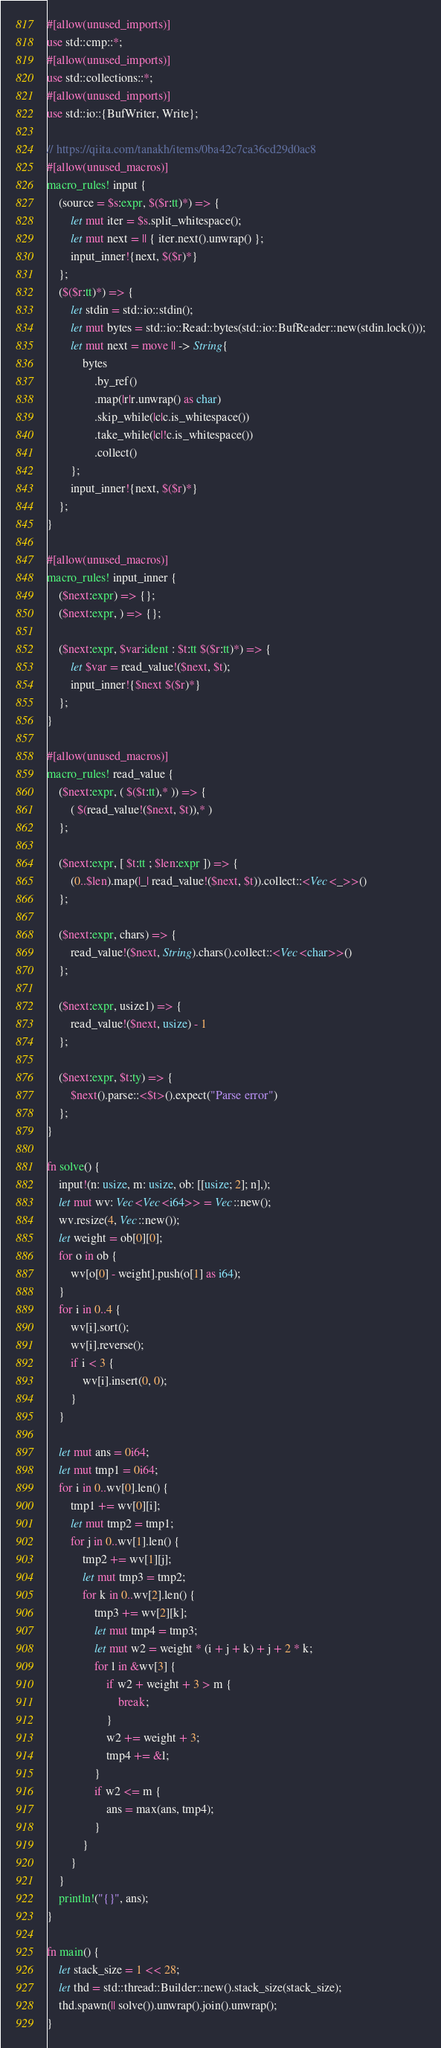<code> <loc_0><loc_0><loc_500><loc_500><_Rust_>#[allow(unused_imports)]
use std::cmp::*;
#[allow(unused_imports)]
use std::collections::*;
#[allow(unused_imports)]
use std::io::{BufWriter, Write};

// https://qiita.com/tanakh/items/0ba42c7ca36cd29d0ac8
#[allow(unused_macros)]
macro_rules! input {
    (source = $s:expr, $($r:tt)*) => {
        let mut iter = $s.split_whitespace();
        let mut next = || { iter.next().unwrap() };
        input_inner!{next, $($r)*}
    };
    ($($r:tt)*) => {
        let stdin = std::io::stdin();
        let mut bytes = std::io::Read::bytes(std::io::BufReader::new(stdin.lock()));
        let mut next = move || -> String{
            bytes
                .by_ref()
                .map(|r|r.unwrap() as char)
                .skip_while(|c|c.is_whitespace())
                .take_while(|c|!c.is_whitespace())
                .collect()
        };
        input_inner!{next, $($r)*}
    };
}

#[allow(unused_macros)]
macro_rules! input_inner {
    ($next:expr) => {};
    ($next:expr, ) => {};

    ($next:expr, $var:ident : $t:tt $($r:tt)*) => {
        let $var = read_value!($next, $t);
        input_inner!{$next $($r)*}
    };
}

#[allow(unused_macros)]
macro_rules! read_value {
    ($next:expr, ( $($t:tt),* )) => {
        ( $(read_value!($next, $t)),* )
    };

    ($next:expr, [ $t:tt ; $len:expr ]) => {
        (0..$len).map(|_| read_value!($next, $t)).collect::<Vec<_>>()
    };

    ($next:expr, chars) => {
        read_value!($next, String).chars().collect::<Vec<char>>()
    };

    ($next:expr, usize1) => {
        read_value!($next, usize) - 1
    };

    ($next:expr, $t:ty) => {
        $next().parse::<$t>().expect("Parse error")
    };
}

fn solve() {
    input!(n: usize, m: usize, ob: [[usize; 2]; n],);
    let mut wv: Vec<Vec<i64>> = Vec::new();
    wv.resize(4, Vec::new());
    let weight = ob[0][0];
    for o in ob {
        wv[o[0] - weight].push(o[1] as i64);
    }
    for i in 0..4 {
        wv[i].sort();
        wv[i].reverse();
        if i < 3 {
            wv[i].insert(0, 0);
        }
    }

    let mut ans = 0i64;
    let mut tmp1 = 0i64;
    for i in 0..wv[0].len() {
        tmp1 += wv[0][i];
        let mut tmp2 = tmp1;
        for j in 0..wv[1].len() {
            tmp2 += wv[1][j];
            let mut tmp3 = tmp2;
            for k in 0..wv[2].len() {
                tmp3 += wv[2][k];
                let mut tmp4 = tmp3;
                let mut w2 = weight * (i + j + k) + j + 2 * k;
                for l in &wv[3] {
                    if w2 + weight + 3 > m {
                        break;
                    }
                    w2 += weight + 3;
                    tmp4 += &l;
                }
                if w2 <= m {
                    ans = max(ans, tmp4);
                }
            }
        }
    }
    println!("{}", ans);
}

fn main() {
    let stack_size = 1 << 28;
    let thd = std::thread::Builder::new().stack_size(stack_size);
    thd.spawn(|| solve()).unwrap().join().unwrap();
}
</code> 